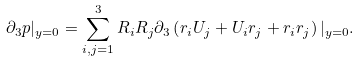<formula> <loc_0><loc_0><loc_500><loc_500>\partial _ { 3 } p | _ { y = 0 } = \sum _ { i , j = 1 } ^ { 3 } R _ { i } R _ { j } \partial _ { 3 } \left ( r _ { i } U _ { j } + U _ { i } r _ { j } + r _ { i } r _ { j } \right ) | _ { y = 0 } .</formula> 